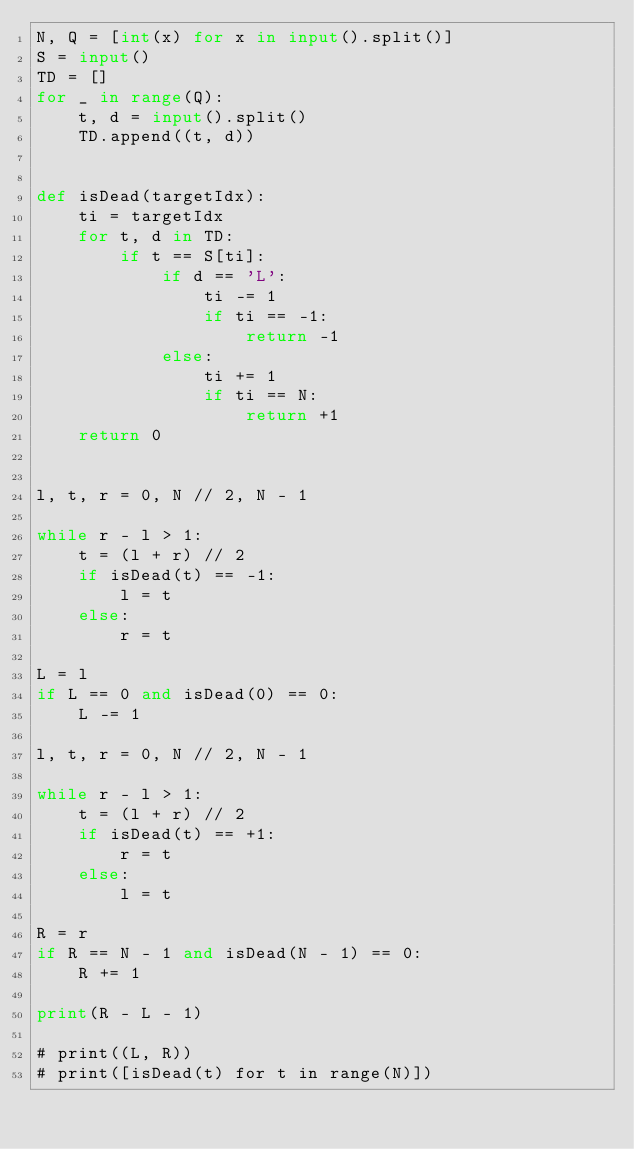Convert code to text. <code><loc_0><loc_0><loc_500><loc_500><_Python_>N, Q = [int(x) for x in input().split()]
S = input()
TD = []
for _ in range(Q):
    t, d = input().split()
    TD.append((t, d))


def isDead(targetIdx):
    ti = targetIdx
    for t, d in TD:
        if t == S[ti]:
            if d == 'L':
                ti -= 1
                if ti == -1:
                    return -1
            else:
                ti += 1
                if ti == N:
                    return +1
    return 0


l, t, r = 0, N // 2, N - 1

while r - l > 1:
    t = (l + r) // 2
    if isDead(t) == -1:
        l = t
    else:
        r = t

L = l
if L == 0 and isDead(0) == 0:
    L -= 1

l, t, r = 0, N // 2, N - 1

while r - l > 1:
    t = (l + r) // 2
    if isDead(t) == +1:
        r = t
    else:
        l = t

R = r
if R == N - 1 and isDead(N - 1) == 0:
    R += 1

print(R - L - 1)

# print((L, R))
# print([isDead(t) for t in range(N)])
</code> 